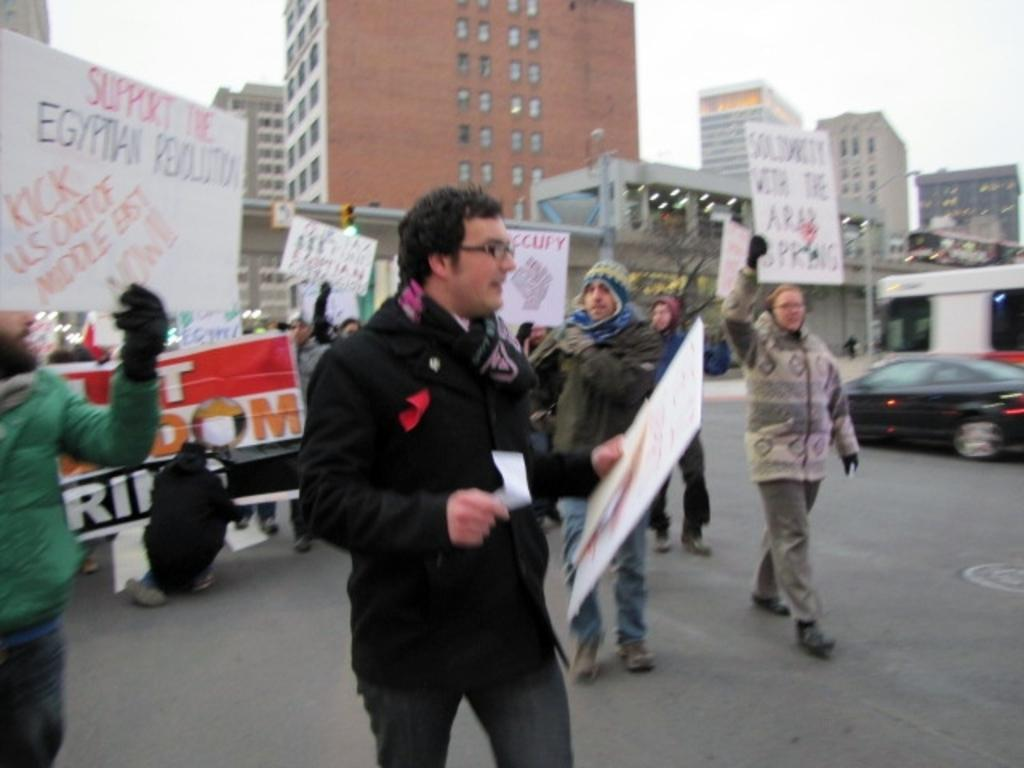What are the persons in the image doing? The persons in the image are standing and holding cardboards. What is written on the cardboards? There is writing on the cardboards. What can be seen in the background of the image? There are buildings in the background of the image. What type of plastic is covering the persons' faces in the image? There is no plastic covering the persons' faces in the image; they are holding cardboards with writing on them. What type of veil is being used by the persons in the image? There is no veil present in the image; the persons are holding cardboards with writing on them. 